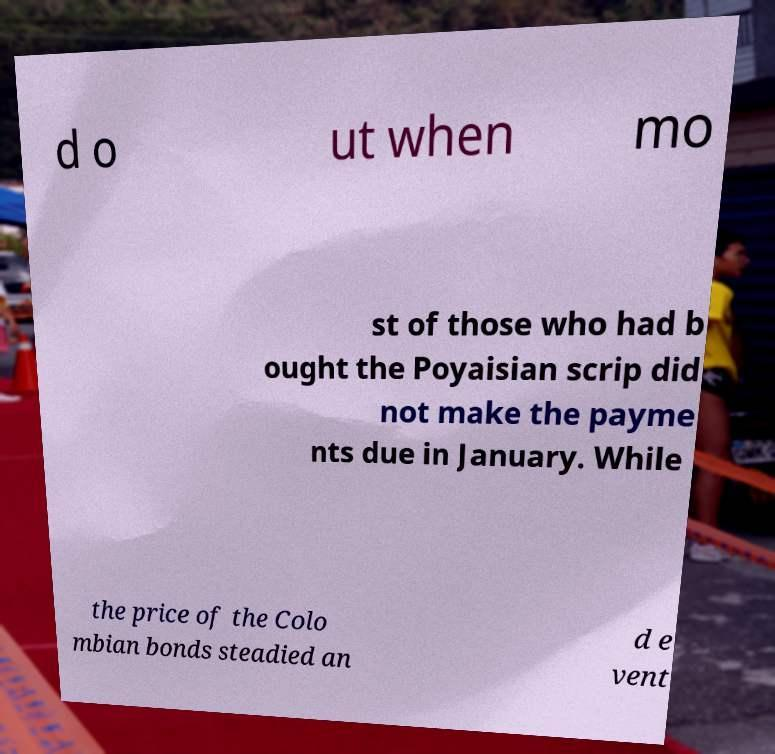For documentation purposes, I need the text within this image transcribed. Could you provide that? d o ut when mo st of those who had b ought the Poyaisian scrip did not make the payme nts due in January. While the price of the Colo mbian bonds steadied an d e vent 